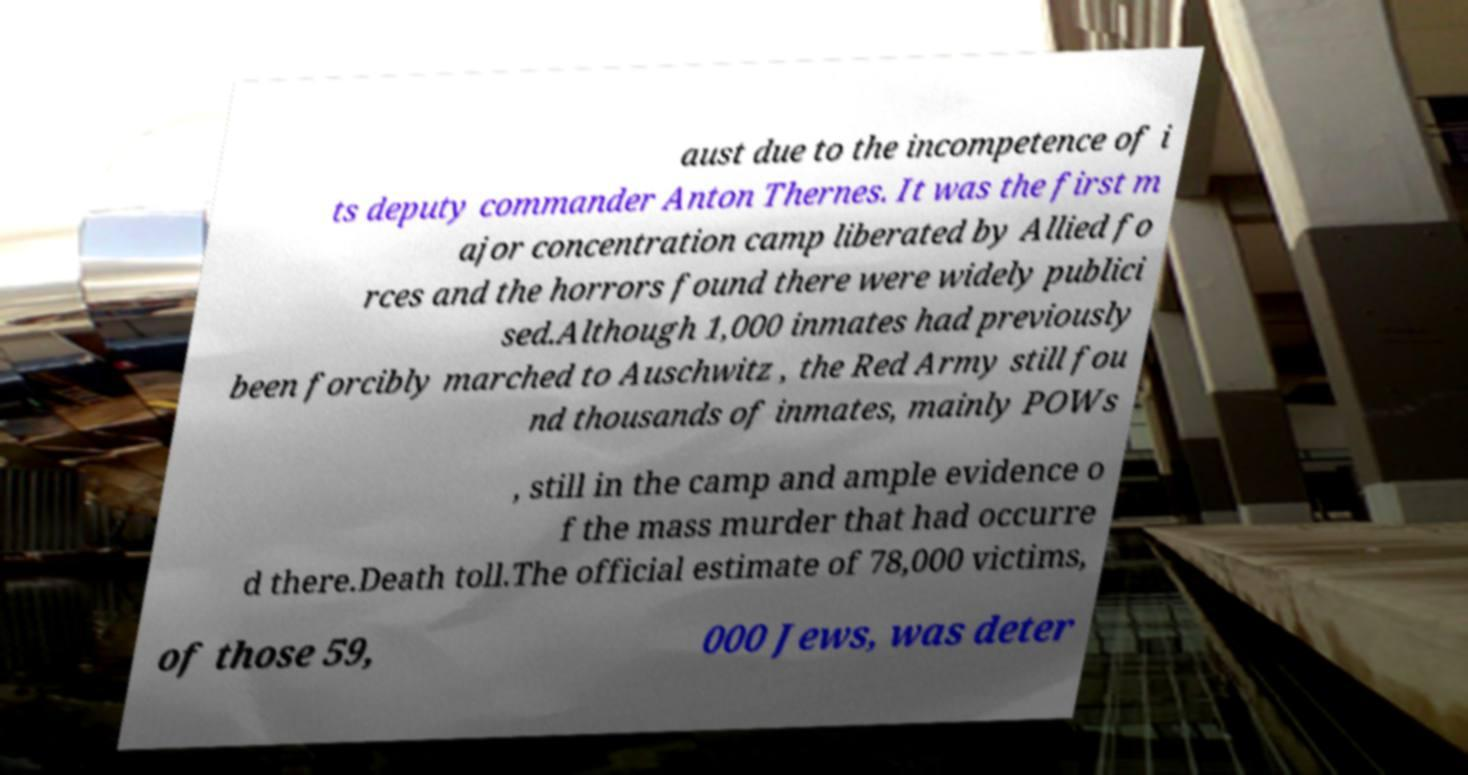Please identify and transcribe the text found in this image. aust due to the incompetence of i ts deputy commander Anton Thernes. It was the first m ajor concentration camp liberated by Allied fo rces and the horrors found there were widely publici sed.Although 1,000 inmates had previously been forcibly marched to Auschwitz , the Red Army still fou nd thousands of inmates, mainly POWs , still in the camp and ample evidence o f the mass murder that had occurre d there.Death toll.The official estimate of 78,000 victims, of those 59, 000 Jews, was deter 